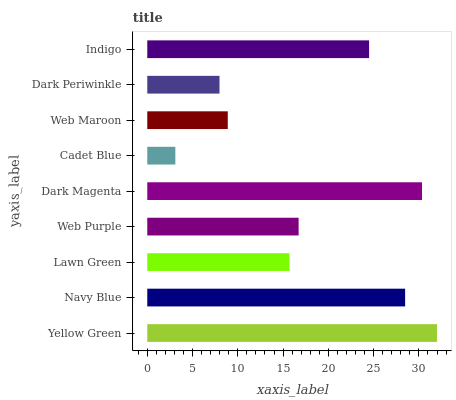Is Cadet Blue the minimum?
Answer yes or no. Yes. Is Yellow Green the maximum?
Answer yes or no. Yes. Is Navy Blue the minimum?
Answer yes or no. No. Is Navy Blue the maximum?
Answer yes or no. No. Is Yellow Green greater than Navy Blue?
Answer yes or no. Yes. Is Navy Blue less than Yellow Green?
Answer yes or no. Yes. Is Navy Blue greater than Yellow Green?
Answer yes or no. No. Is Yellow Green less than Navy Blue?
Answer yes or no. No. Is Web Purple the high median?
Answer yes or no. Yes. Is Web Purple the low median?
Answer yes or no. Yes. Is Web Maroon the high median?
Answer yes or no. No. Is Lawn Green the low median?
Answer yes or no. No. 